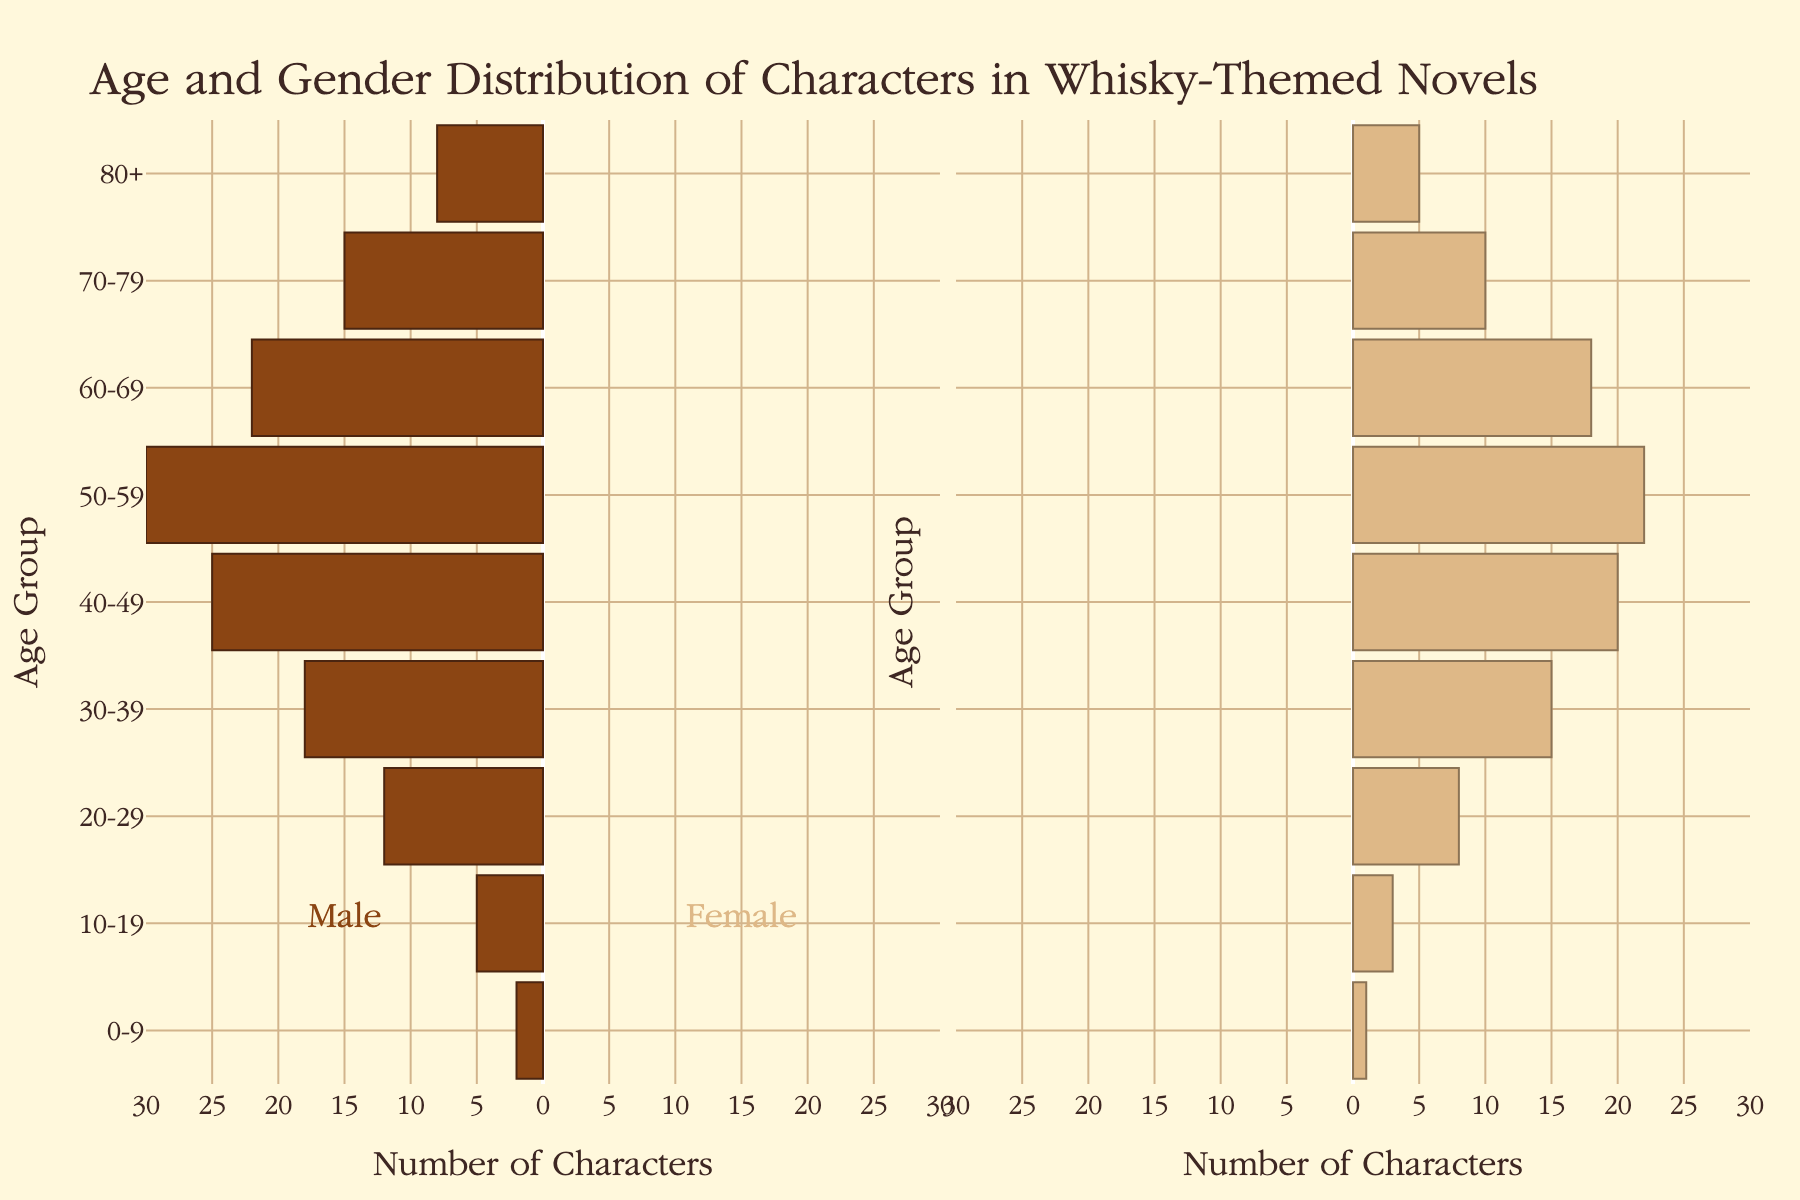What is the title of the figure? The title is typically located at the top of the figure and provides an overview of what the plot represents.
Answer: Age and Gender Distribution of Characters in Whisky-Themed Novels What age group has the highest number of female characters? Look at the female side of the pyramid and identify which age group has the longest bar.
Answer: 50-59 How many male characters are in the 30-39 age group? Examine the male side of the pyramid and read the numerical value corresponding to the 30-39 age group.
Answer: 18 Compare the number of male and female characters in the 40-49 age group. Which gender has more characters? Look at the lengths of the bars for males and females in the 40-49 age group and compare them.
Answer: Male What is the combined total number of characters in the 60-69 age group? Add the number of male characters in the 60-69 age group to the number of female characters in the same age group.
Answer: 40 Which age group has the smallest difference between the number of male and female characters? Calculate the absolute differences between male and female characters for each age group, then compare these differences to find the smallest one.
Answer: 70-79 What is the total number of female characters in the plot? Sum the number of female characters in all age groups.
Answer: 102 How does the number of male characters aged 10-19 compare to those aged 50-59? Look at the male side of the pyramid and compare the length of the bars for the 10-19 and 50-59 age groups.
Answer: 50-59 has more male characters In which age group do male and female characters together make up exactly 30 characters? Identify the age group where the sum of male and female characters equals 30.
Answer: 70-79 How many more male characters are there than female characters in the 20-29 age group? Subtract the number of female characters from the number of male characters in the 20-29 age group.
Answer: 4 